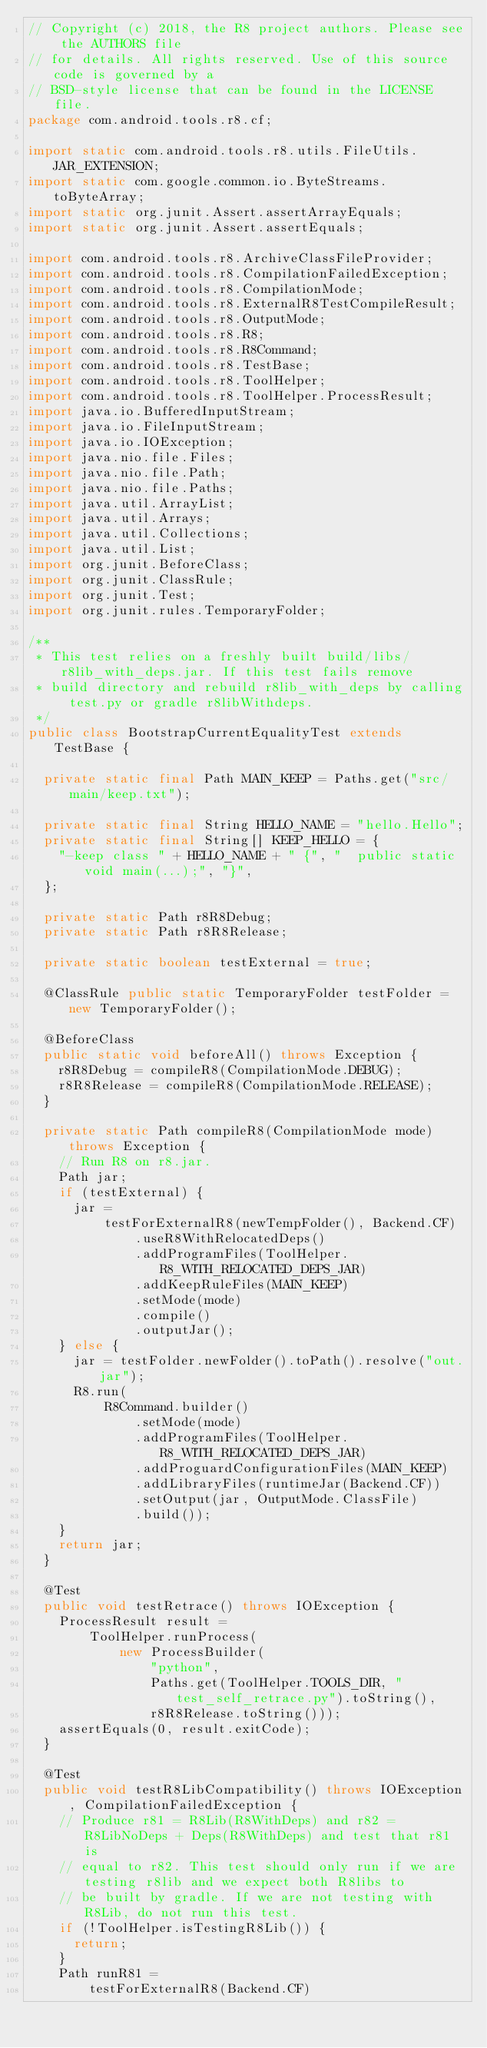Convert code to text. <code><loc_0><loc_0><loc_500><loc_500><_Java_>// Copyright (c) 2018, the R8 project authors. Please see the AUTHORS file
// for details. All rights reserved. Use of this source code is governed by a
// BSD-style license that can be found in the LICENSE file.
package com.android.tools.r8.cf;

import static com.android.tools.r8.utils.FileUtils.JAR_EXTENSION;
import static com.google.common.io.ByteStreams.toByteArray;
import static org.junit.Assert.assertArrayEquals;
import static org.junit.Assert.assertEquals;

import com.android.tools.r8.ArchiveClassFileProvider;
import com.android.tools.r8.CompilationFailedException;
import com.android.tools.r8.CompilationMode;
import com.android.tools.r8.ExternalR8TestCompileResult;
import com.android.tools.r8.OutputMode;
import com.android.tools.r8.R8;
import com.android.tools.r8.R8Command;
import com.android.tools.r8.TestBase;
import com.android.tools.r8.ToolHelper;
import com.android.tools.r8.ToolHelper.ProcessResult;
import java.io.BufferedInputStream;
import java.io.FileInputStream;
import java.io.IOException;
import java.nio.file.Files;
import java.nio.file.Path;
import java.nio.file.Paths;
import java.util.ArrayList;
import java.util.Arrays;
import java.util.Collections;
import java.util.List;
import org.junit.BeforeClass;
import org.junit.ClassRule;
import org.junit.Test;
import org.junit.rules.TemporaryFolder;

/**
 * This test relies on a freshly built build/libs/r8lib_with_deps.jar. If this test fails remove
 * build directory and rebuild r8lib_with_deps by calling test.py or gradle r8libWithdeps.
 */
public class BootstrapCurrentEqualityTest extends TestBase {

  private static final Path MAIN_KEEP = Paths.get("src/main/keep.txt");

  private static final String HELLO_NAME = "hello.Hello";
  private static final String[] KEEP_HELLO = {
    "-keep class " + HELLO_NAME + " {", "  public static void main(...);", "}",
  };

  private static Path r8R8Debug;
  private static Path r8R8Release;

  private static boolean testExternal = true;

  @ClassRule public static TemporaryFolder testFolder = new TemporaryFolder();

  @BeforeClass
  public static void beforeAll() throws Exception {
    r8R8Debug = compileR8(CompilationMode.DEBUG);
    r8R8Release = compileR8(CompilationMode.RELEASE);
  }

  private static Path compileR8(CompilationMode mode) throws Exception {
    // Run R8 on r8.jar.
    Path jar;
    if (testExternal) {
      jar =
          testForExternalR8(newTempFolder(), Backend.CF)
              .useR8WithRelocatedDeps()
              .addProgramFiles(ToolHelper.R8_WITH_RELOCATED_DEPS_JAR)
              .addKeepRuleFiles(MAIN_KEEP)
              .setMode(mode)
              .compile()
              .outputJar();
    } else {
      jar = testFolder.newFolder().toPath().resolve("out.jar");
      R8.run(
          R8Command.builder()
              .setMode(mode)
              .addProgramFiles(ToolHelper.R8_WITH_RELOCATED_DEPS_JAR)
              .addProguardConfigurationFiles(MAIN_KEEP)
              .addLibraryFiles(runtimeJar(Backend.CF))
              .setOutput(jar, OutputMode.ClassFile)
              .build());
    }
    return jar;
  }

  @Test
  public void testRetrace() throws IOException {
    ProcessResult result =
        ToolHelper.runProcess(
            new ProcessBuilder(
                "python",
                Paths.get(ToolHelper.TOOLS_DIR, "test_self_retrace.py").toString(),
                r8R8Release.toString()));
    assertEquals(0, result.exitCode);
  }

  @Test
  public void testR8LibCompatibility() throws IOException, CompilationFailedException {
    // Produce r81 = R8Lib(R8WithDeps) and r82 = R8LibNoDeps + Deps(R8WithDeps) and test that r81 is
    // equal to r82. This test should only run if we are testing r8lib and we expect both R8libs to
    // be built by gradle. If we are not testing with R8Lib, do not run this test.
    if (!ToolHelper.isTestingR8Lib()) {
      return;
    }
    Path runR81 =
        testForExternalR8(Backend.CF)</code> 